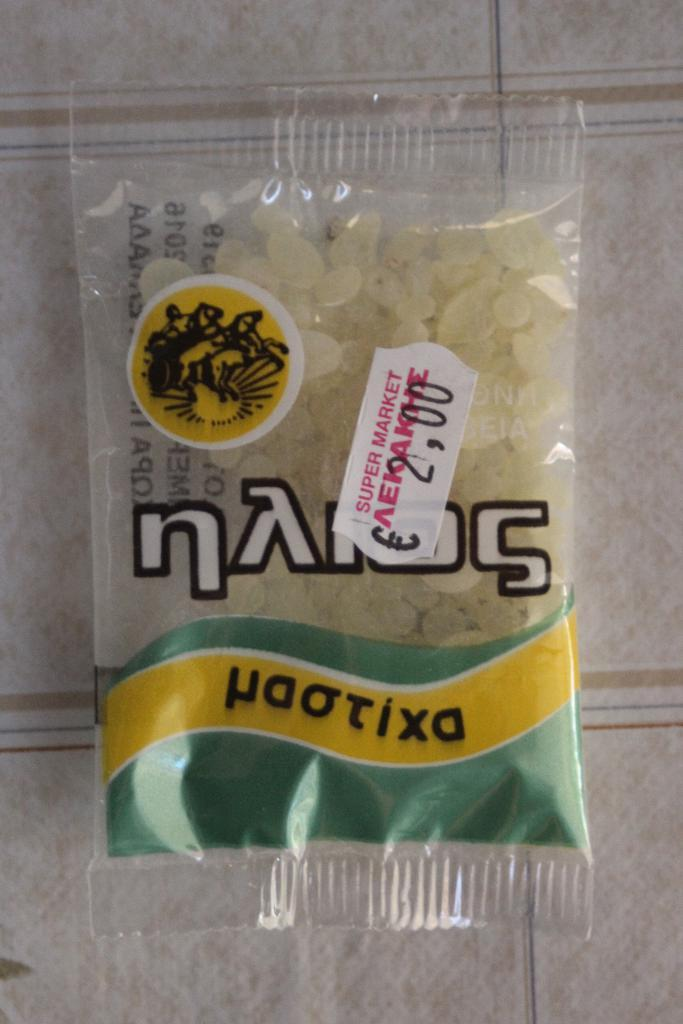What is present on the floor in the image? There is a packet with food items on the floor. Can you describe the contents of the packet? The provided facts do not specify the contents of the packet, only that it contains food items. How many cows are visible in the image? There are no cows present in the image. What type of coat is the person wearing in the image? There is no person or coat visible in the image; it only features a packet with food items on the floor. 